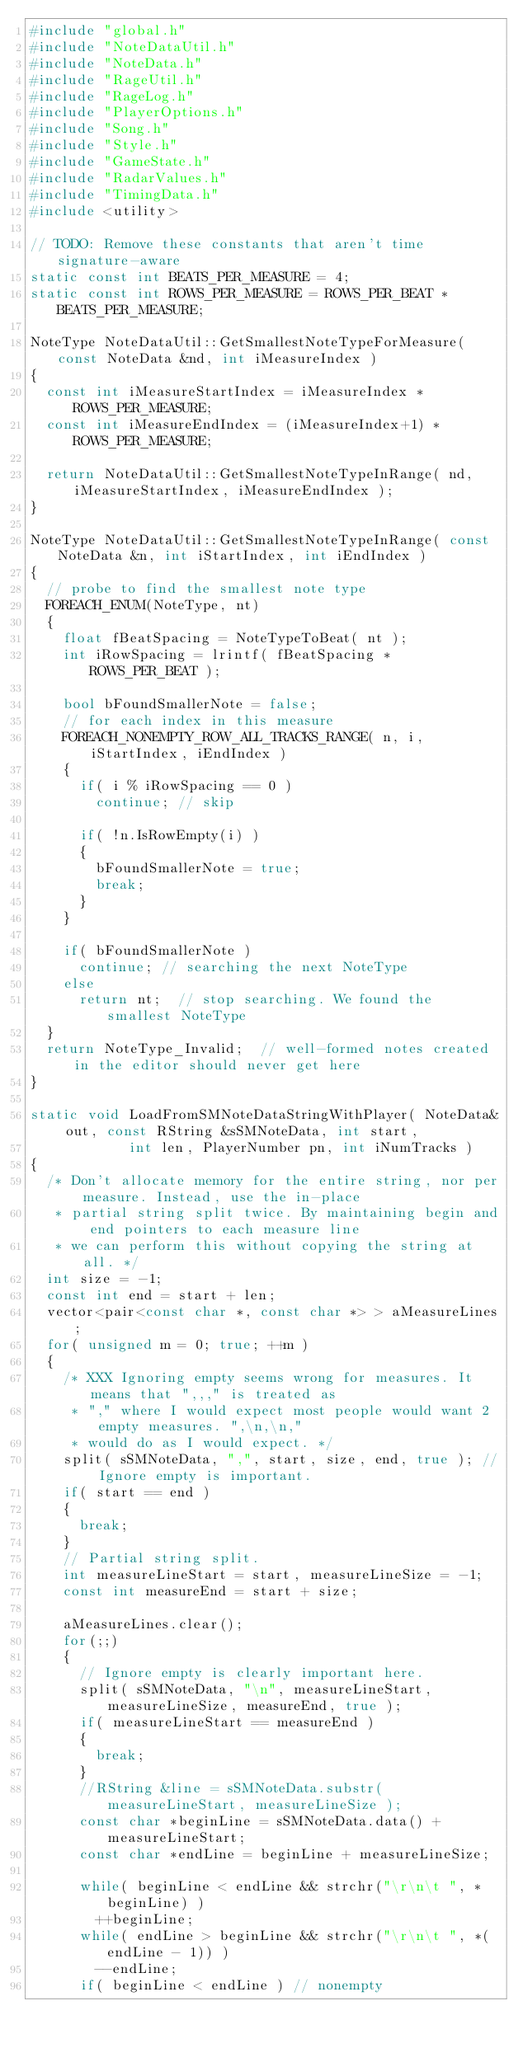Convert code to text. <code><loc_0><loc_0><loc_500><loc_500><_C++_>#include "global.h"
#include "NoteDataUtil.h"
#include "NoteData.h"
#include "RageUtil.h"
#include "RageLog.h"
#include "PlayerOptions.h"
#include "Song.h"
#include "Style.h"
#include "GameState.h"
#include "RadarValues.h"
#include "TimingData.h"
#include <utility>

// TODO: Remove these constants that aren't time signature-aware
static const int BEATS_PER_MEASURE = 4;
static const int ROWS_PER_MEASURE = ROWS_PER_BEAT * BEATS_PER_MEASURE;

NoteType NoteDataUtil::GetSmallestNoteTypeForMeasure( const NoteData &nd, int iMeasureIndex )
{
	const int iMeasureStartIndex = iMeasureIndex * ROWS_PER_MEASURE;
	const int iMeasureEndIndex = (iMeasureIndex+1) * ROWS_PER_MEASURE;

	return NoteDataUtil::GetSmallestNoteTypeInRange( nd, iMeasureStartIndex, iMeasureEndIndex );
}

NoteType NoteDataUtil::GetSmallestNoteTypeInRange( const NoteData &n, int iStartIndex, int iEndIndex )
{
	// probe to find the smallest note type
	FOREACH_ENUM(NoteType, nt)
	{
		float fBeatSpacing = NoteTypeToBeat( nt );
		int iRowSpacing = lrintf( fBeatSpacing * ROWS_PER_BEAT );

		bool bFoundSmallerNote = false;
		// for each index in this measure
		FOREACH_NONEMPTY_ROW_ALL_TRACKS_RANGE( n, i, iStartIndex, iEndIndex )
		{
			if( i % iRowSpacing == 0 )
				continue;	// skip
			
			if( !n.IsRowEmpty(i) )
			{
				bFoundSmallerNote = true;
				break;
			}
		}

		if( bFoundSmallerNote )
			continue;	// searching the next NoteType
		else
			return nt;	// stop searching. We found the smallest NoteType
	}
	return NoteType_Invalid;	// well-formed notes created in the editor should never get here
}

static void LoadFromSMNoteDataStringWithPlayer( NoteData& out, const RString &sSMNoteData, int start,
						int len, PlayerNumber pn, int iNumTracks )
{
	/* Don't allocate memory for the entire string, nor per measure. Instead, use the in-place
	 * partial string split twice. By maintaining begin and end pointers to each measure line
	 * we can perform this without copying the string at all. */
	int size = -1;
	const int end = start + len;
	vector<pair<const char *, const char *> > aMeasureLines;
	for( unsigned m = 0; true; ++m )
	{
		/* XXX Ignoring empty seems wrong for measures. It means that ",,," is treated as
		 * "," where I would expect most people would want 2 empty measures. ",\n,\n,"
		 * would do as I would expect. */
		split( sSMNoteData, ",", start, size, end, true ); // Ignore empty is important.
		if( start == end )
		{
			break;
		}
		// Partial string split.
		int measureLineStart = start, measureLineSize = -1;
		const int measureEnd = start + size;

		aMeasureLines.clear();
		for(;;)
		{
			// Ignore empty is clearly important here.
			split( sSMNoteData, "\n", measureLineStart, measureLineSize, measureEnd, true );
			if( measureLineStart == measureEnd )
			{
				break;
			}
			//RString &line = sSMNoteData.substr( measureLineStart, measureLineSize );
			const char *beginLine = sSMNoteData.data() + measureLineStart;
			const char *endLine = beginLine + measureLineSize;

			while( beginLine < endLine && strchr("\r\n\t ", *beginLine) )
				++beginLine;
			while( endLine > beginLine && strchr("\r\n\t ", *(endLine - 1)) )
				--endLine;
			if( beginLine < endLine ) // nonempty</code> 